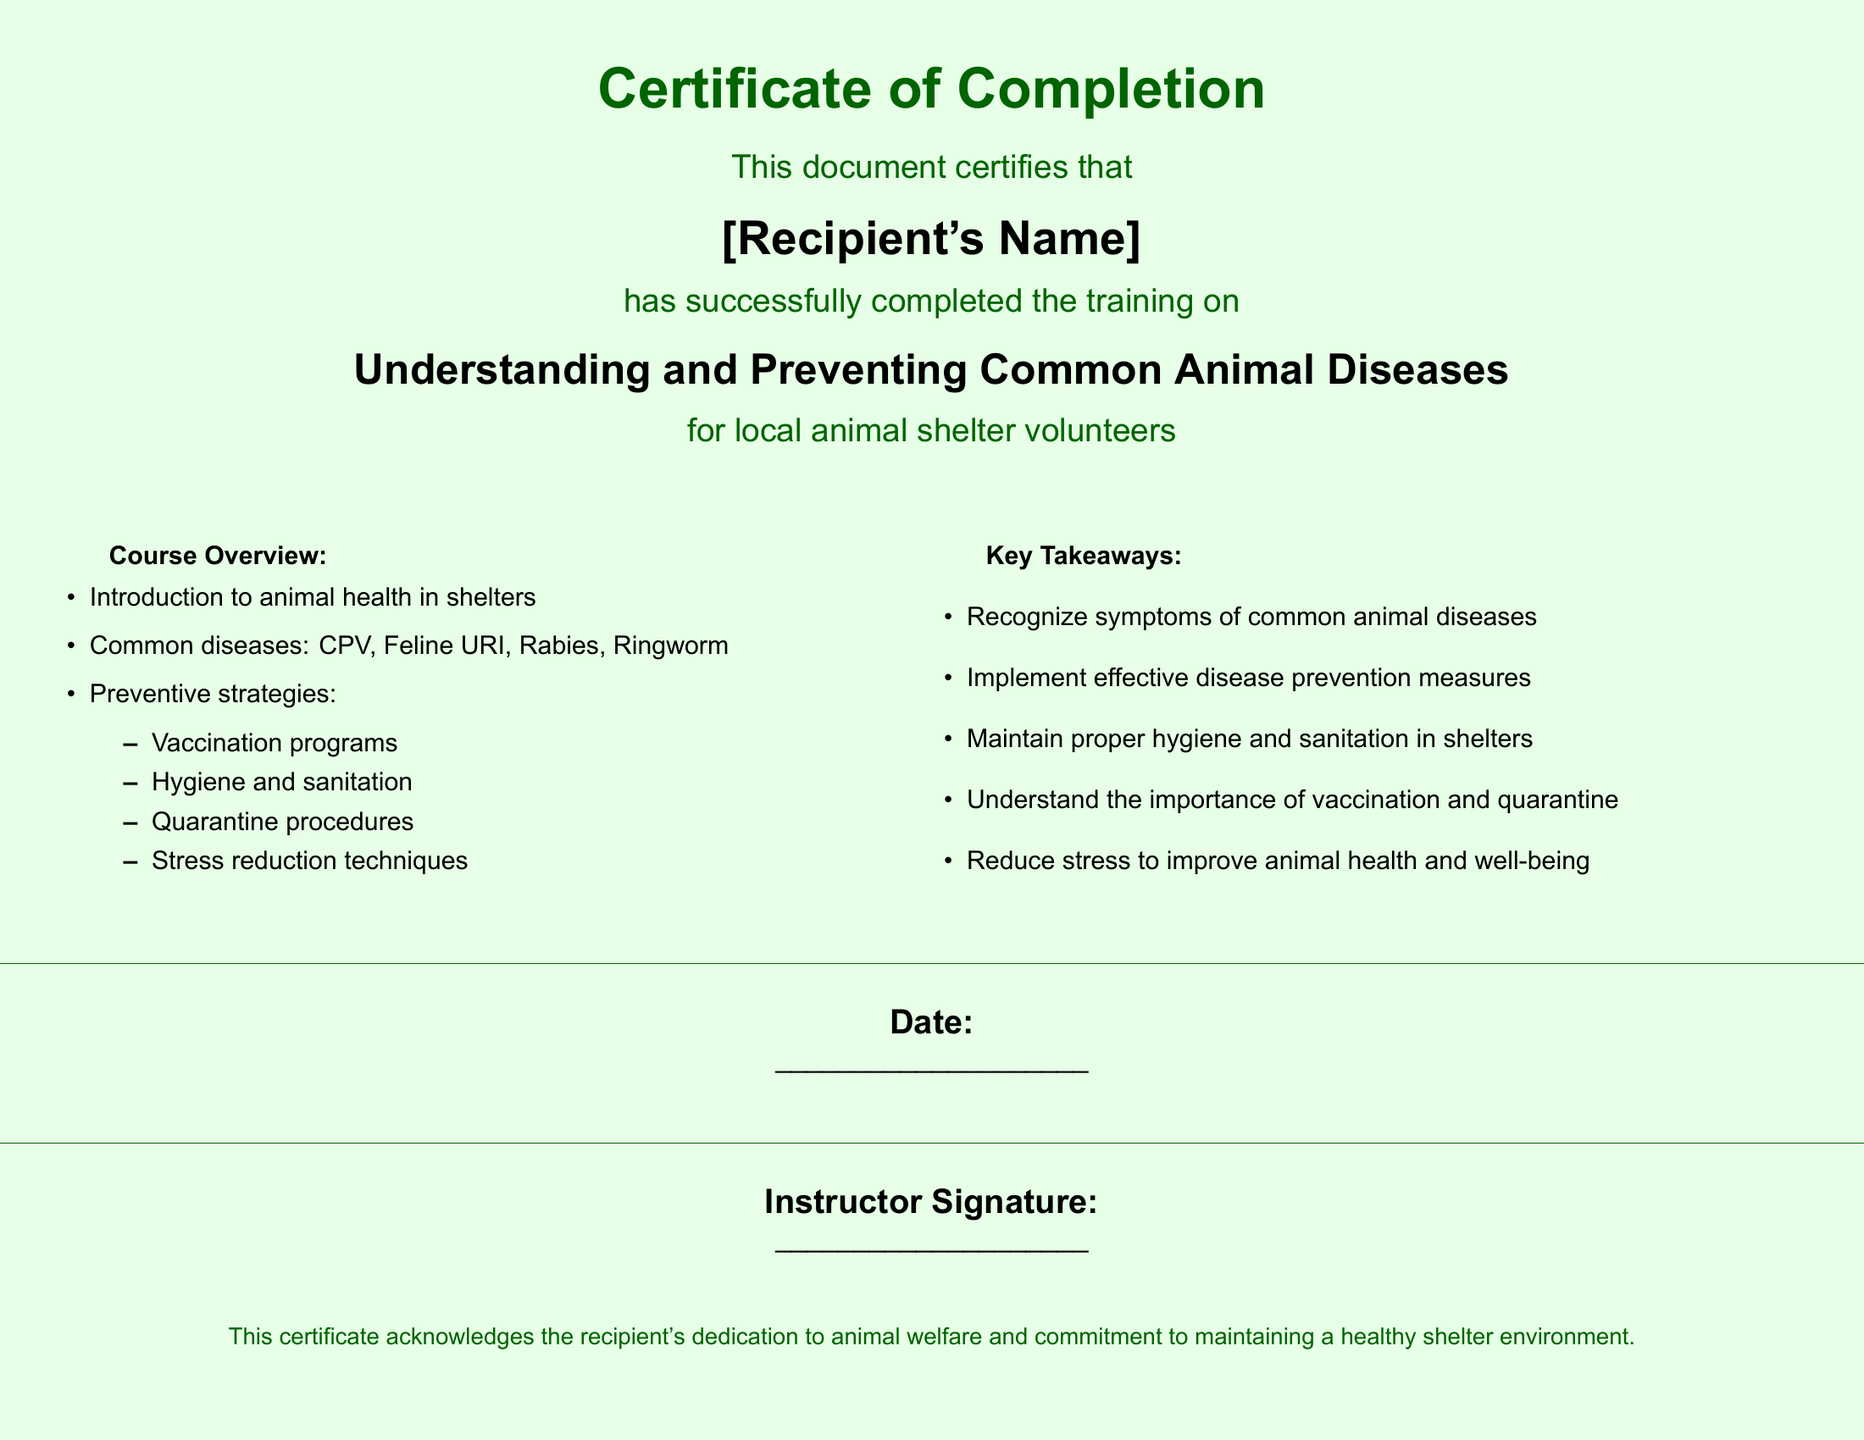What is the title of the training course? The title of the training course is explicitly mentioned in the document.
Answer: Understanding and Preventing Common Animal Diseases Who has completed the training? The recipient's name is specified where it indicates who completed the training.
Answer: [Recipient's Name] What are two common diseases mentioned in the course overview? The document lists common diseases in the course overview section.
Answer: CPV, Feline URI What is one preventive strategy discussed in the document? The document outlines several preventive strategies in a bullet point format.
Answer: Vaccination programs What is the primary focus of the certificate? The document states the main purpose of the certificate clearly.
Answer: Animal welfare and commitment to maintaining a healthy shelter environment How many key takeaways are listed in the document? The number of key takeaways can be counted from the list provided in the document.
Answer: Five What color is the background of the certificate? The document describes the background color used throughout the certificate.
Answer: Light green What is the instructor's responsibility as noted in the document? The document requires an instructor's signature, implying their role in verifying completion.
Answer: Instructor Signature What type of document is this? The document can be identified by its specific certificate format and purpose.
Answer: Certificate of Completion 